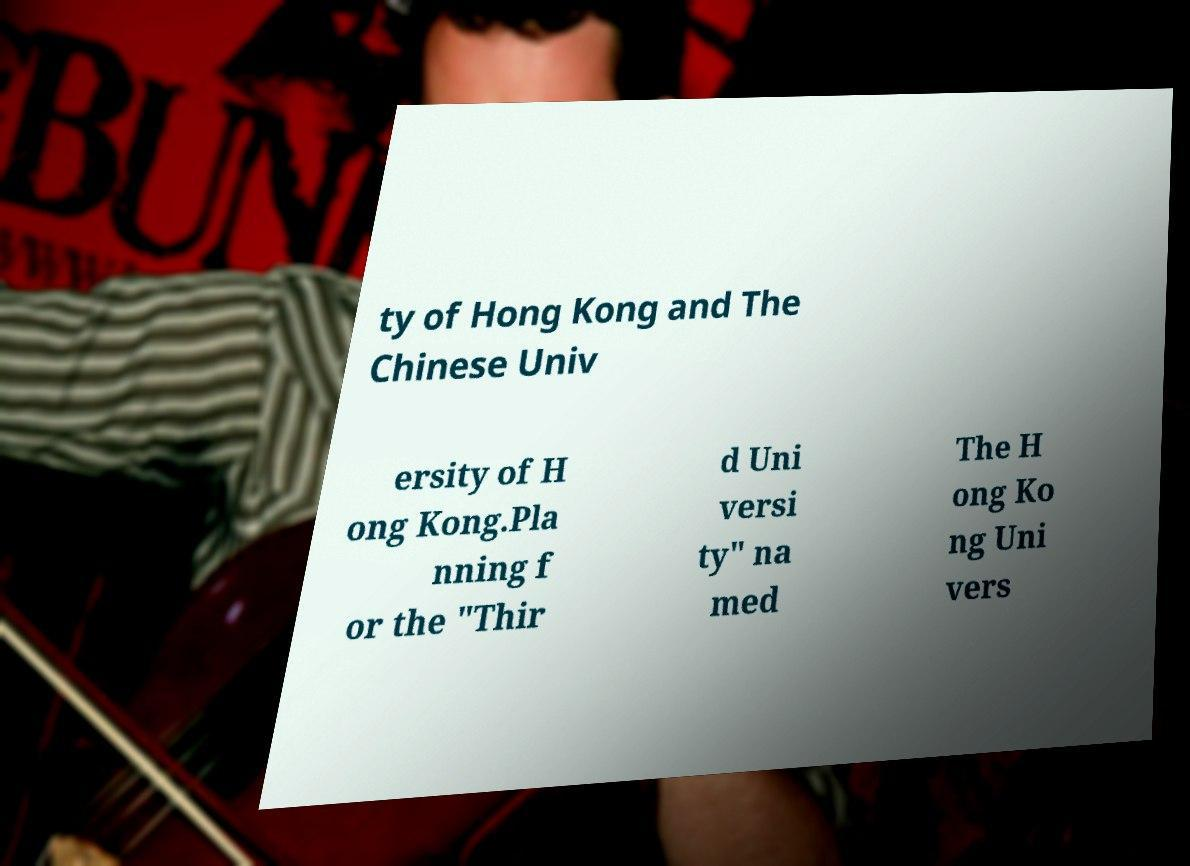There's text embedded in this image that I need extracted. Can you transcribe it verbatim? ty of Hong Kong and The Chinese Univ ersity of H ong Kong.Pla nning f or the "Thir d Uni versi ty" na med The H ong Ko ng Uni vers 